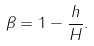Convert formula to latex. <formula><loc_0><loc_0><loc_500><loc_500>\beta = 1 - \frac { h } { H } .</formula> 